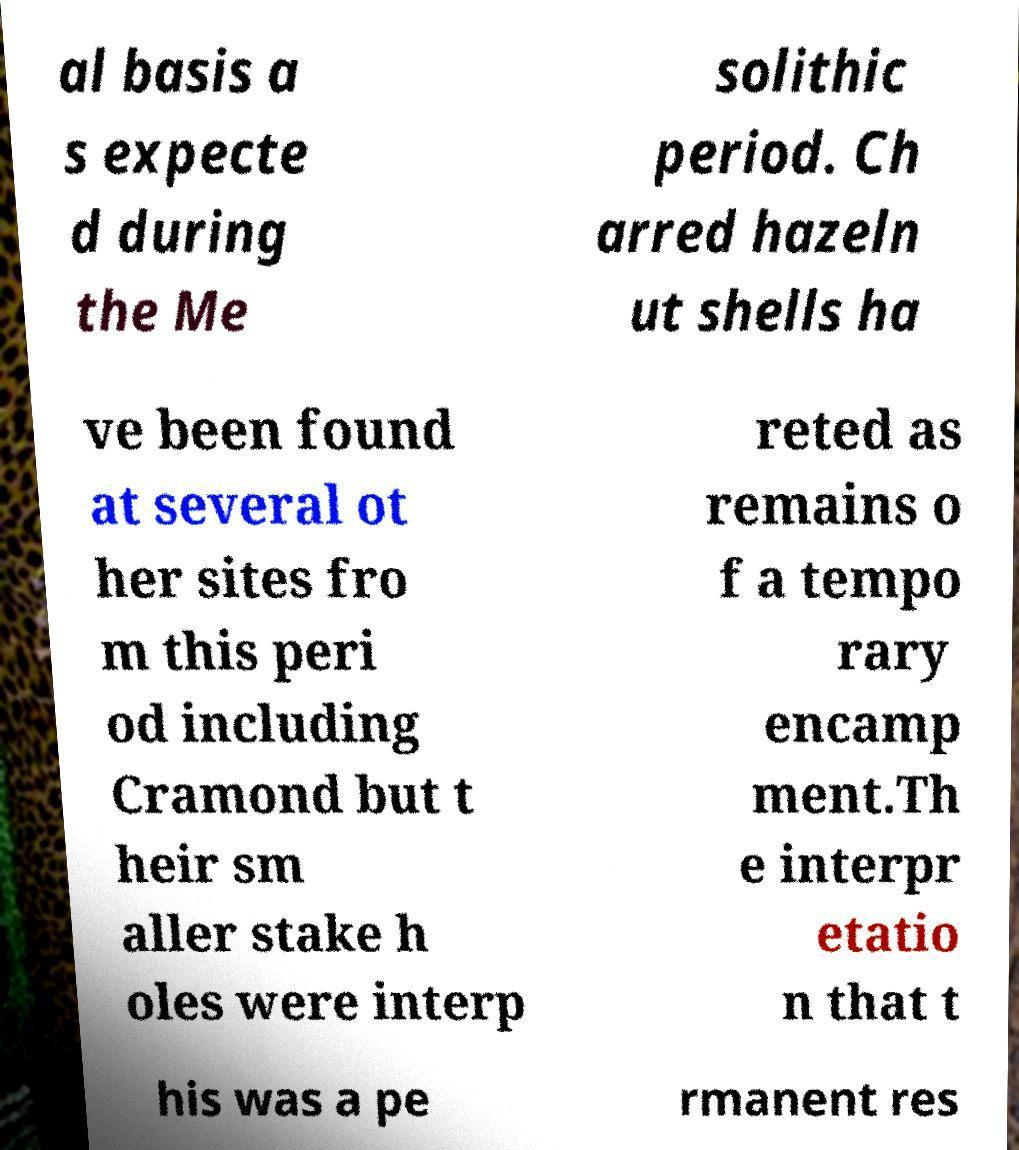Can you accurately transcribe the text from the provided image for me? al basis a s expecte d during the Me solithic period. Ch arred hazeln ut shells ha ve been found at several ot her sites fro m this peri od including Cramond but t heir sm aller stake h oles were interp reted as remains o f a tempo rary encamp ment.Th e interpr etatio n that t his was a pe rmanent res 